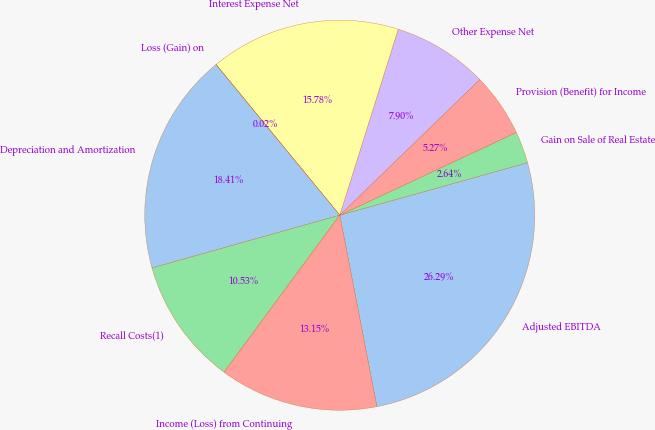<chart> <loc_0><loc_0><loc_500><loc_500><pie_chart><fcel>Adjusted EBITDA<fcel>Gain on Sale of Real Estate<fcel>Provision (Benefit) for Income<fcel>Other Expense Net<fcel>Interest Expense Net<fcel>Loss (Gain) on<fcel>Depreciation and Amortization<fcel>Recall Costs(1)<fcel>Income (Loss) from Continuing<nl><fcel>26.29%<fcel>2.64%<fcel>5.27%<fcel>7.9%<fcel>15.78%<fcel>0.02%<fcel>18.41%<fcel>10.53%<fcel>13.15%<nl></chart> 